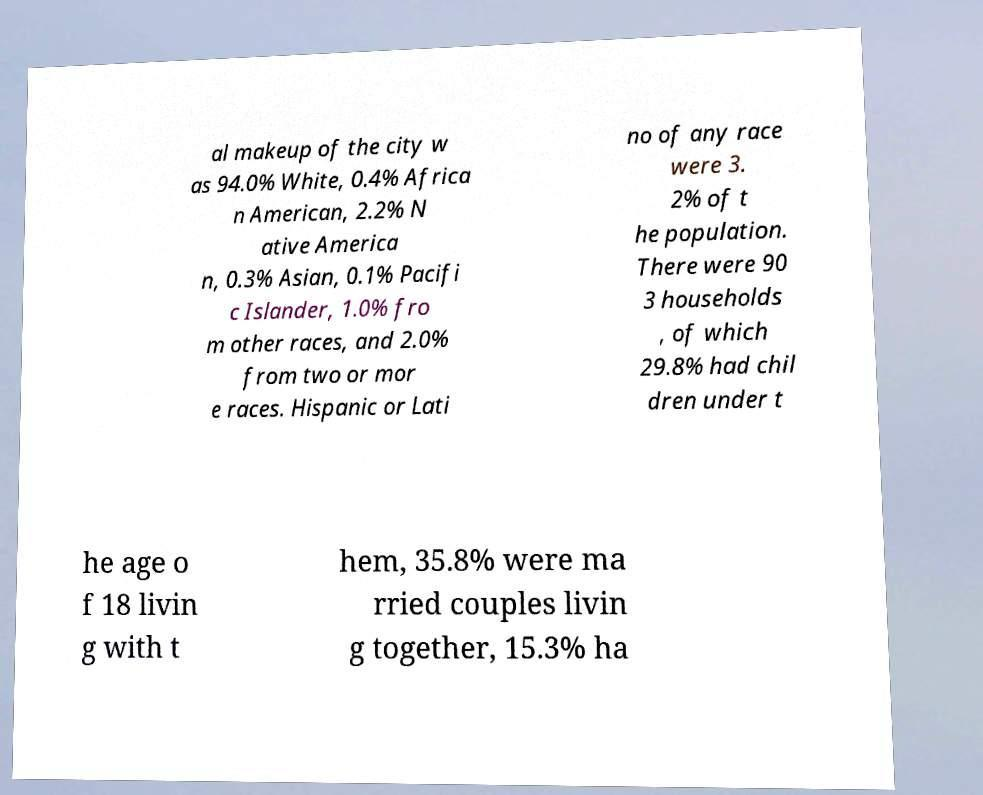What messages or text are displayed in this image? I need them in a readable, typed format. al makeup of the city w as 94.0% White, 0.4% Africa n American, 2.2% N ative America n, 0.3% Asian, 0.1% Pacifi c Islander, 1.0% fro m other races, and 2.0% from two or mor e races. Hispanic or Lati no of any race were 3. 2% of t he population. There were 90 3 households , of which 29.8% had chil dren under t he age o f 18 livin g with t hem, 35.8% were ma rried couples livin g together, 15.3% ha 